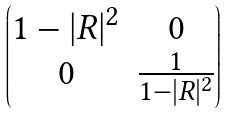Convert formula to latex. <formula><loc_0><loc_0><loc_500><loc_500>\begin{pmatrix} 1 - | R | ^ { 2 } & 0 \\ 0 & \frac { 1 } { 1 - | R | ^ { 2 } } \end{pmatrix}</formula> 